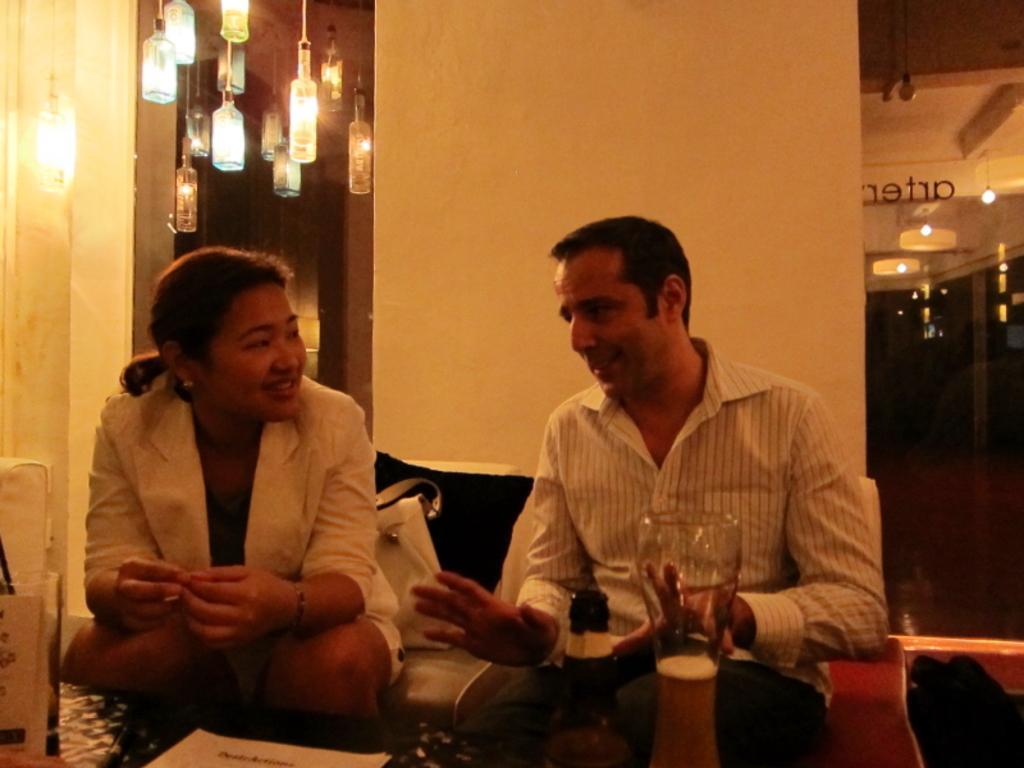In one or two sentences, can you explain what this image depicts? In the foreground of this image, there is a woman and a man sitting on the sofas in front of a table on which there are bottle, glass, papers and few objects. In the background, there are lights, wall, glass and a bag behind the woman. 